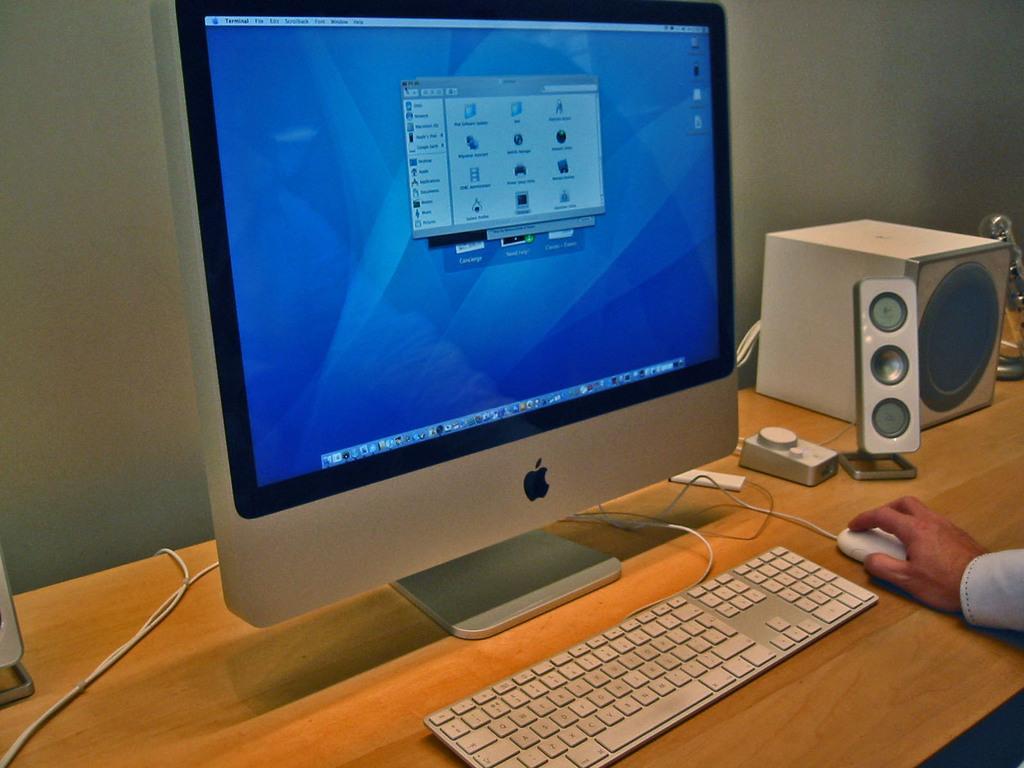Can you describe this image briefly? There is a computer in the foreground area of the image on a desk, there are speakers and a hand on the mouse on the right side. 